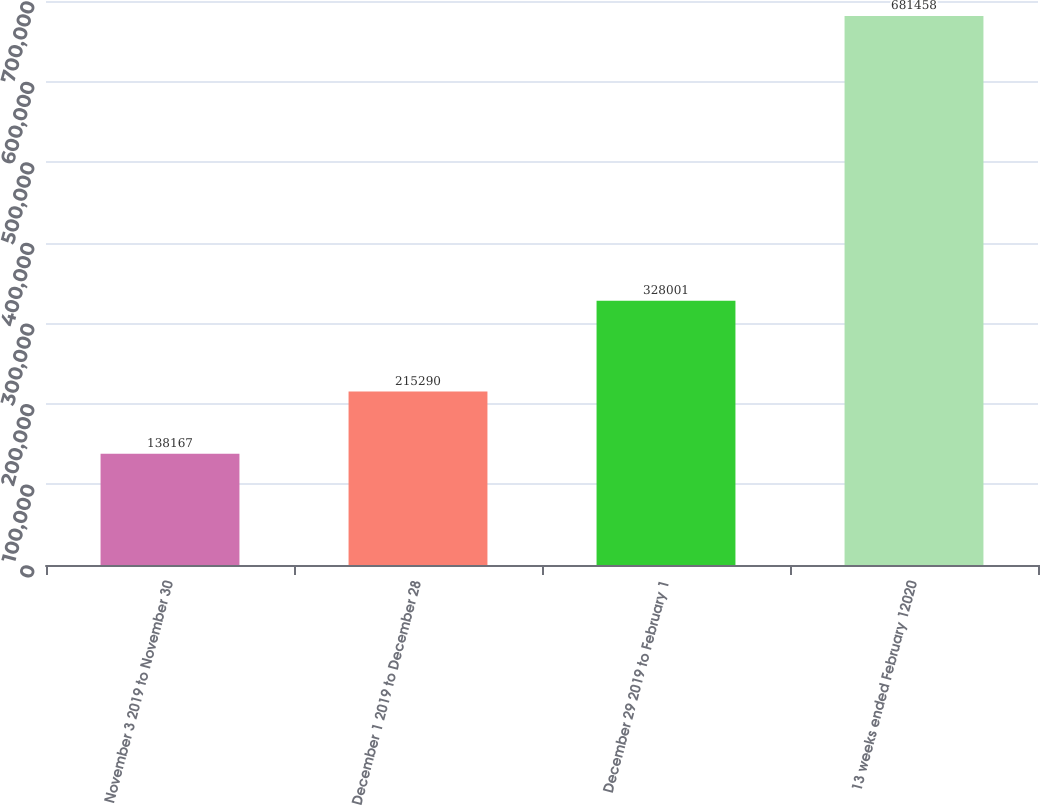Convert chart. <chart><loc_0><loc_0><loc_500><loc_500><bar_chart><fcel>November 3 2019 to November 30<fcel>December 1 2019 to December 28<fcel>December 29 2019 to February 1<fcel>13 weeks ended February 12020<nl><fcel>138167<fcel>215290<fcel>328001<fcel>681458<nl></chart> 